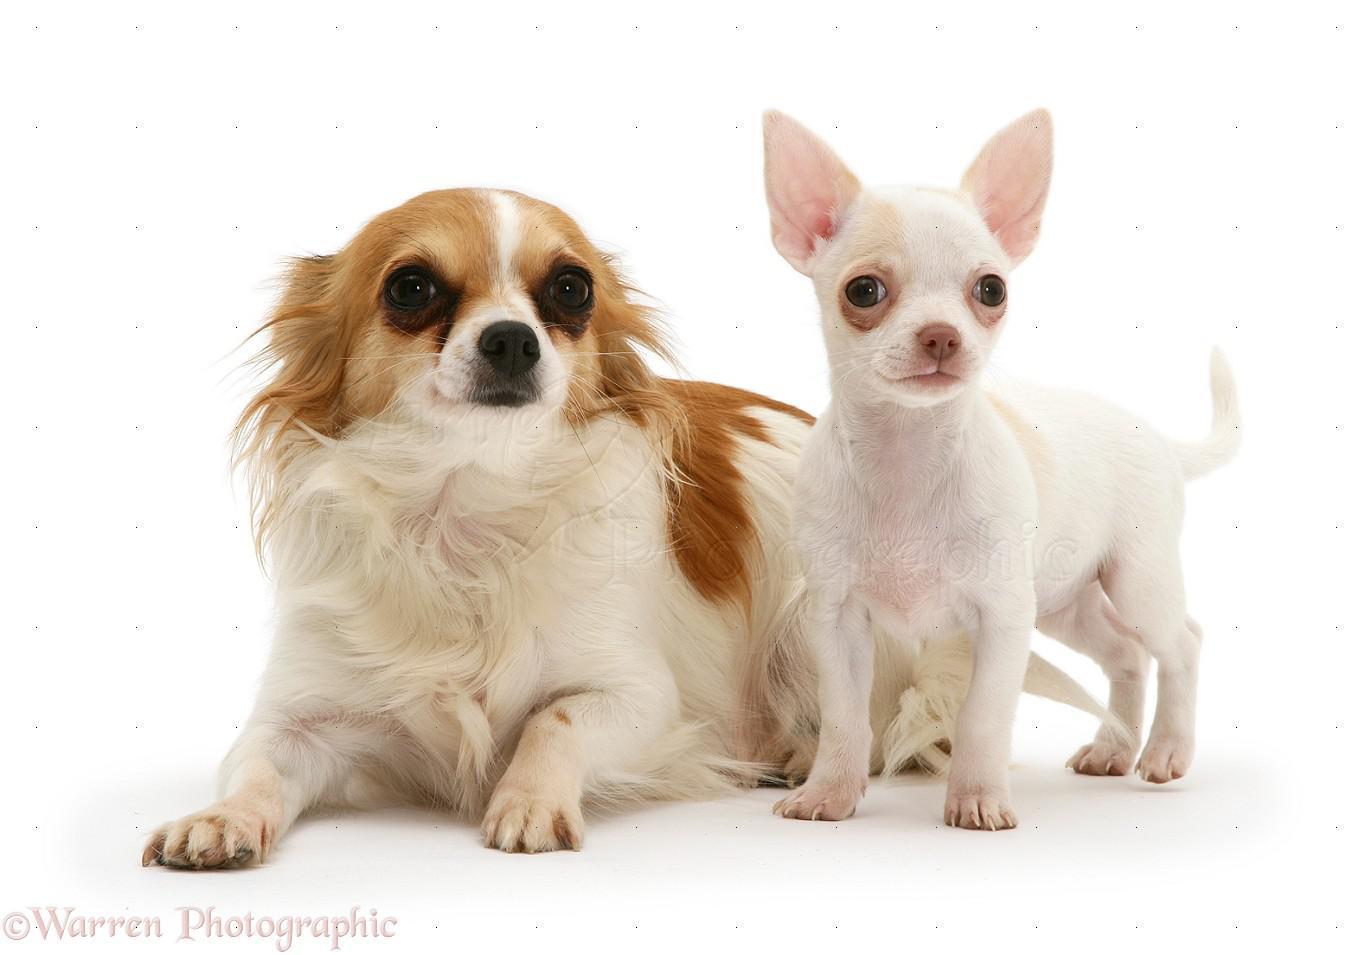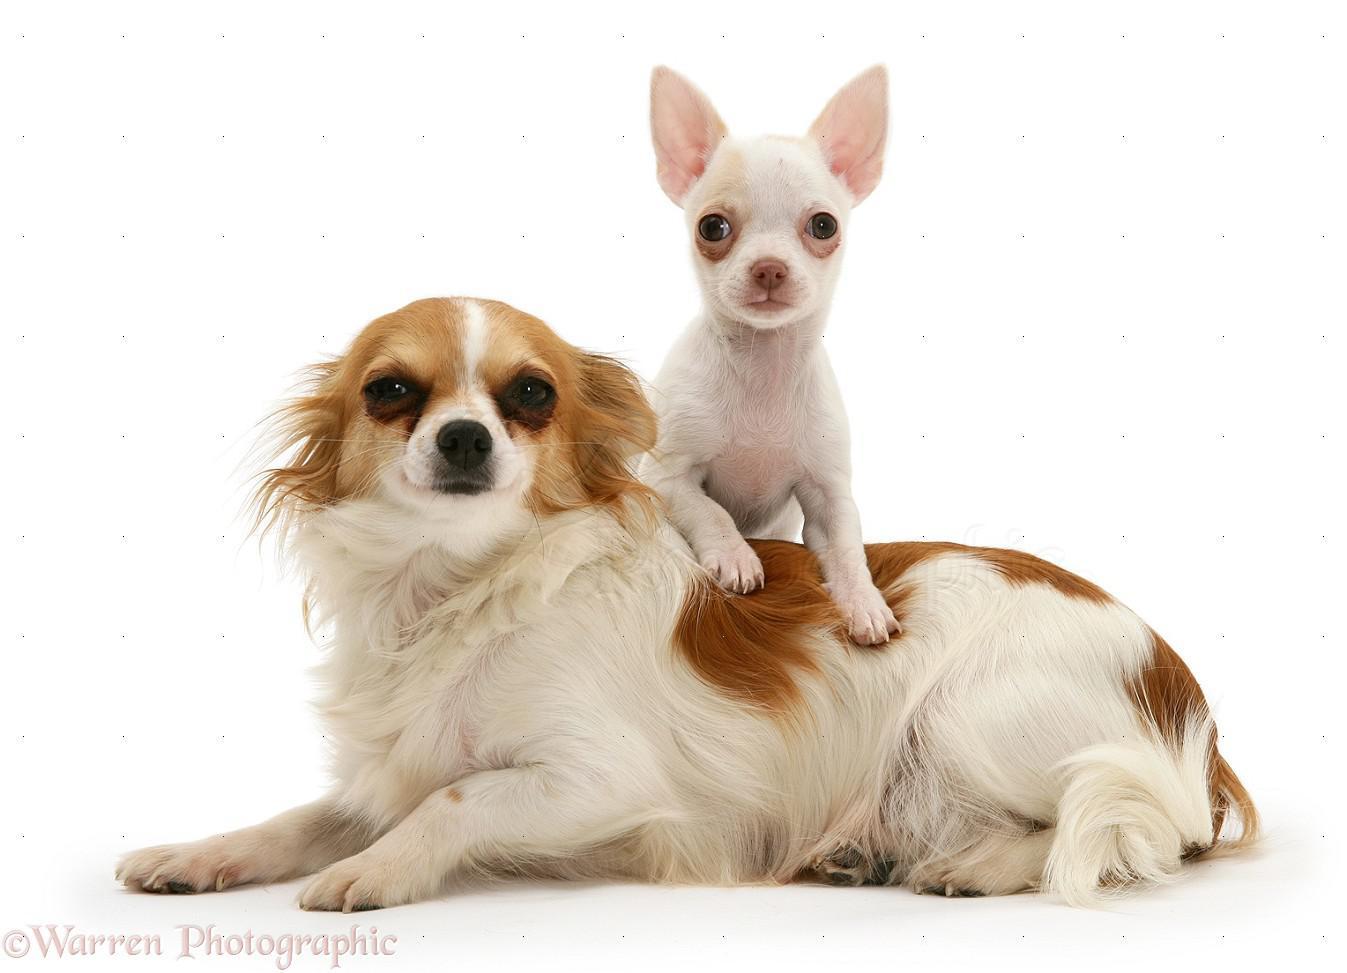The first image is the image on the left, the second image is the image on the right. Evaluate the accuracy of this statement regarding the images: "In the right image, a chihuahua is wearing an object around its neck.". Is it true? Answer yes or no. No. The first image is the image on the left, the second image is the image on the right. Evaluate the accuracy of this statement regarding the images: "Of the two dogs shown, one dog's ears are floppy or folded, and the other dog's ears are pointy and erect.". Is it true? Answer yes or no. Yes. 